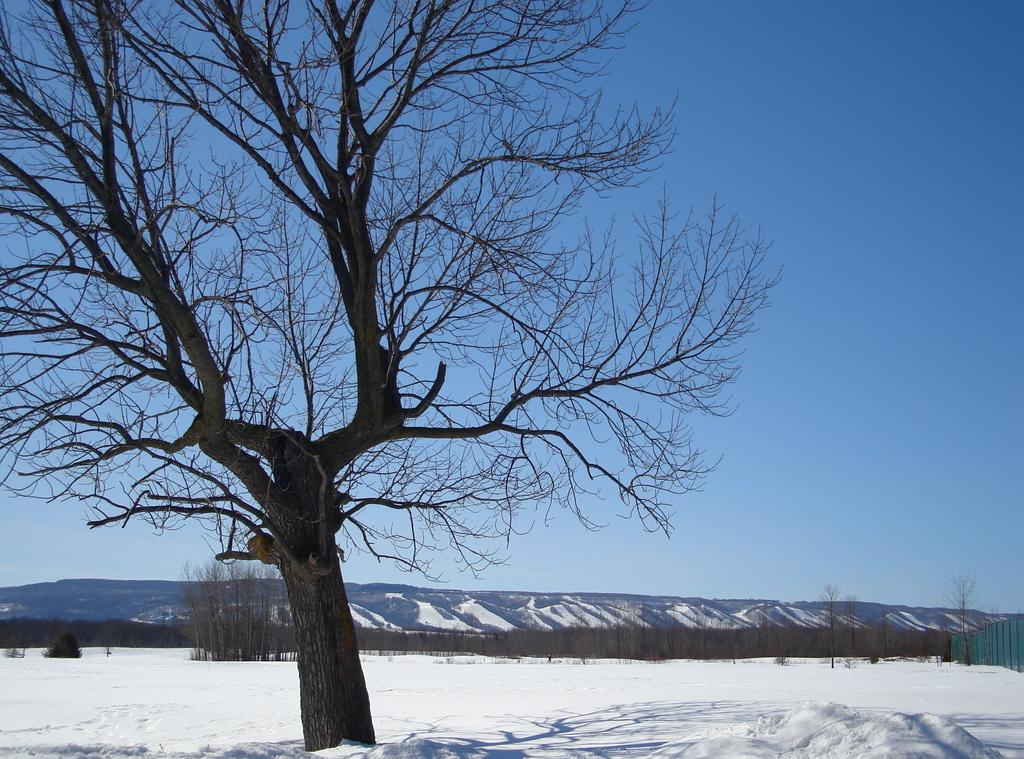What is located on the left side of the image? There is a tree on the left side of the image. What type of weather is depicted in the image? There is snow at the bottom of the image, indicating a winter scene. What is visible at the top of the image? The sky is visible at the top of the image. What type of fruit is hanging from the tree in the image? There is no fruit visible on the tree in the image. What is the minister doing in the image? There is no minister present in the image. 